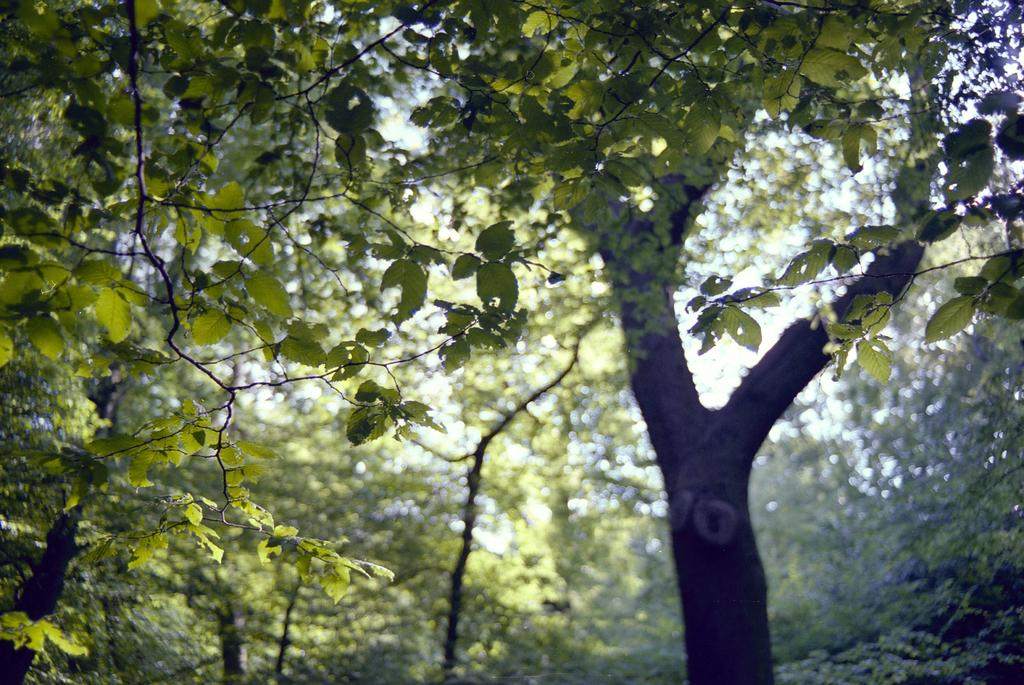What type of vegetation is present in the image? There are many trees in the image. What part of the trees can be seen in the image? Leaves are visible in the image. What is visible in the background of the image? There is a sky visible in the background of the image. What type of fang can be seen in the image? There are no fangs present in the image; it features trees and leaves. What is being served for lunch in the image? There is no reference to lunch or any food in the image. 